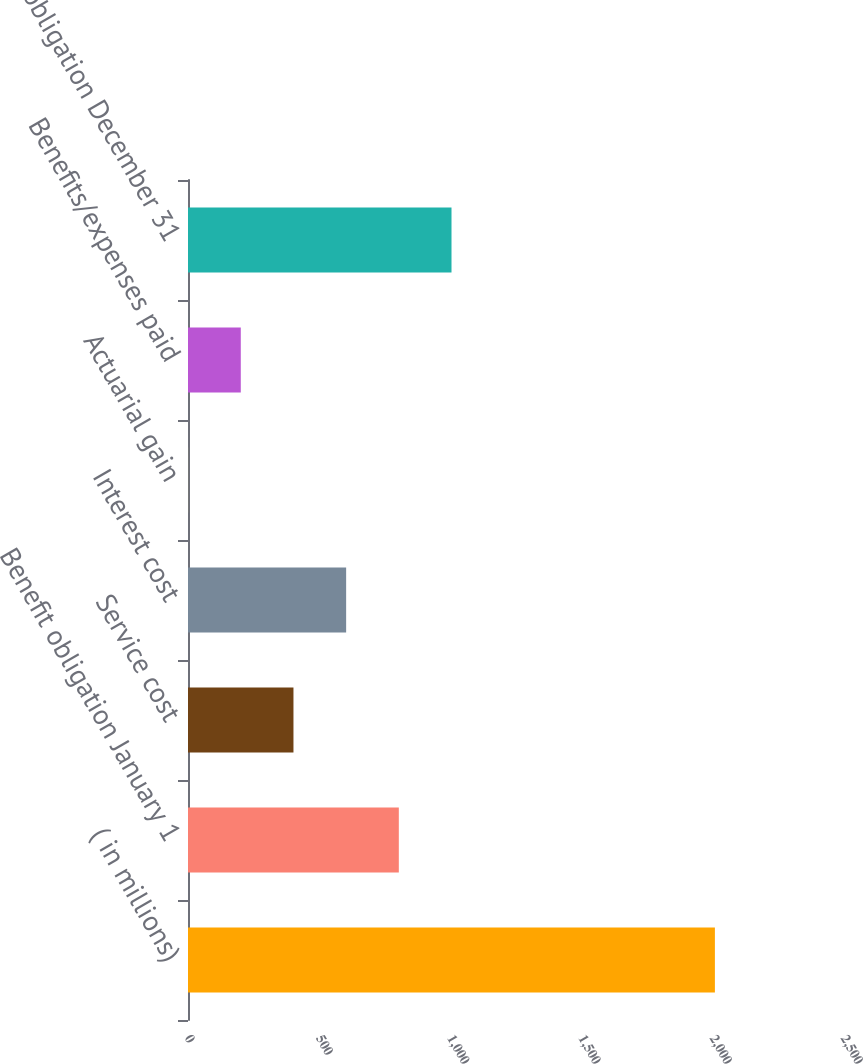Convert chart to OTSL. <chart><loc_0><loc_0><loc_500><loc_500><bar_chart><fcel>( in millions)<fcel>Benefit obligation January 1<fcel>Service cost<fcel>Interest cost<fcel>Actuarial gain<fcel>Benefits/expenses paid<fcel>Benefit obligation December 31<nl><fcel>2008<fcel>803.44<fcel>401.92<fcel>602.68<fcel>0.4<fcel>201.16<fcel>1004.2<nl></chart> 